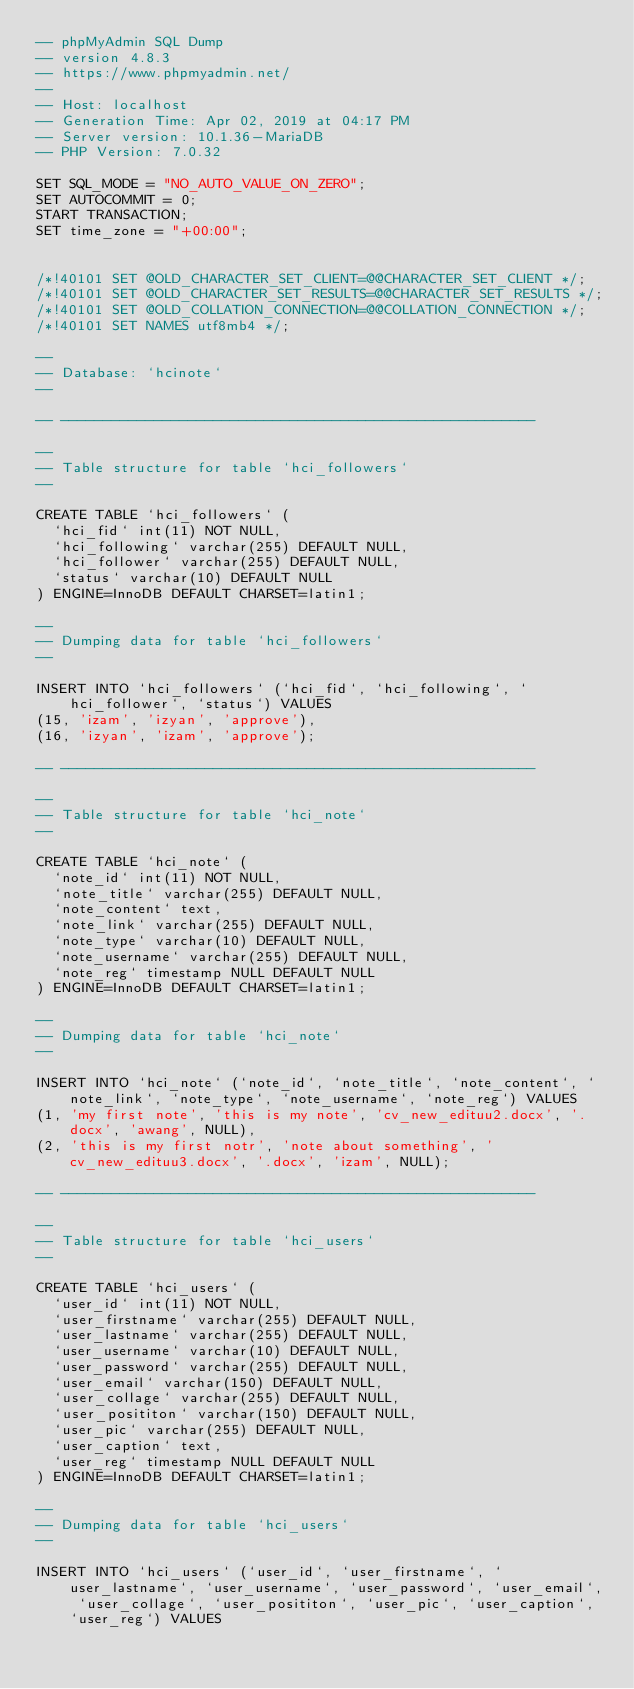Convert code to text. <code><loc_0><loc_0><loc_500><loc_500><_SQL_>-- phpMyAdmin SQL Dump
-- version 4.8.3
-- https://www.phpmyadmin.net/
--
-- Host: localhost
-- Generation Time: Apr 02, 2019 at 04:17 PM
-- Server version: 10.1.36-MariaDB
-- PHP Version: 7.0.32

SET SQL_MODE = "NO_AUTO_VALUE_ON_ZERO";
SET AUTOCOMMIT = 0;
START TRANSACTION;
SET time_zone = "+00:00";


/*!40101 SET @OLD_CHARACTER_SET_CLIENT=@@CHARACTER_SET_CLIENT */;
/*!40101 SET @OLD_CHARACTER_SET_RESULTS=@@CHARACTER_SET_RESULTS */;
/*!40101 SET @OLD_COLLATION_CONNECTION=@@COLLATION_CONNECTION */;
/*!40101 SET NAMES utf8mb4 */;

--
-- Database: `hcinote`
--

-- --------------------------------------------------------

--
-- Table structure for table `hci_followers`
--

CREATE TABLE `hci_followers` (
  `hci_fid` int(11) NOT NULL,
  `hci_following` varchar(255) DEFAULT NULL,
  `hci_follower` varchar(255) DEFAULT NULL,
  `status` varchar(10) DEFAULT NULL
) ENGINE=InnoDB DEFAULT CHARSET=latin1;

--
-- Dumping data for table `hci_followers`
--

INSERT INTO `hci_followers` (`hci_fid`, `hci_following`, `hci_follower`, `status`) VALUES
(15, 'izam', 'izyan', 'approve'),
(16, 'izyan', 'izam', 'approve');

-- --------------------------------------------------------

--
-- Table structure for table `hci_note`
--

CREATE TABLE `hci_note` (
  `note_id` int(11) NOT NULL,
  `note_title` varchar(255) DEFAULT NULL,
  `note_content` text,
  `note_link` varchar(255) DEFAULT NULL,
  `note_type` varchar(10) DEFAULT NULL,
  `note_username` varchar(255) DEFAULT NULL,
  `note_reg` timestamp NULL DEFAULT NULL
) ENGINE=InnoDB DEFAULT CHARSET=latin1;

--
-- Dumping data for table `hci_note`
--

INSERT INTO `hci_note` (`note_id`, `note_title`, `note_content`, `note_link`, `note_type`, `note_username`, `note_reg`) VALUES
(1, 'my first note', 'this is my note', 'cv_new_edituu2.docx', '.docx', 'awang', NULL),
(2, 'this is my first notr', 'note about something', 'cv_new_edituu3.docx', '.docx', 'izam', NULL);

-- --------------------------------------------------------

--
-- Table structure for table `hci_users`
--

CREATE TABLE `hci_users` (
  `user_id` int(11) NOT NULL,
  `user_firstname` varchar(255) DEFAULT NULL,
  `user_lastname` varchar(255) DEFAULT NULL,
  `user_username` varchar(10) DEFAULT NULL,
  `user_password` varchar(255) DEFAULT NULL,
  `user_email` varchar(150) DEFAULT NULL,
  `user_collage` varchar(255) DEFAULT NULL,
  `user_posititon` varchar(150) DEFAULT NULL,
  `user_pic` varchar(255) DEFAULT NULL,
  `user_caption` text,
  `user_reg` timestamp NULL DEFAULT NULL
) ENGINE=InnoDB DEFAULT CHARSET=latin1;

--
-- Dumping data for table `hci_users`
--

INSERT INTO `hci_users` (`user_id`, `user_firstname`, `user_lastname`, `user_username`, `user_password`, `user_email`, `user_collage`, `user_posititon`, `user_pic`, `user_caption`, `user_reg`) VALUES</code> 